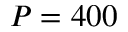<formula> <loc_0><loc_0><loc_500><loc_500>P = 4 0 0</formula> 